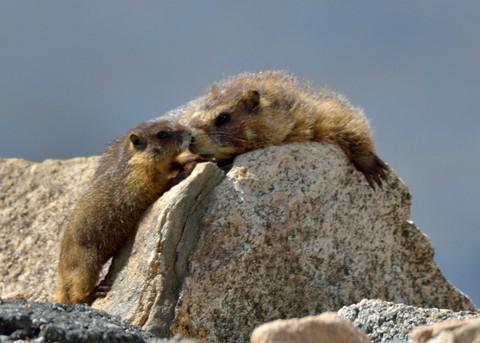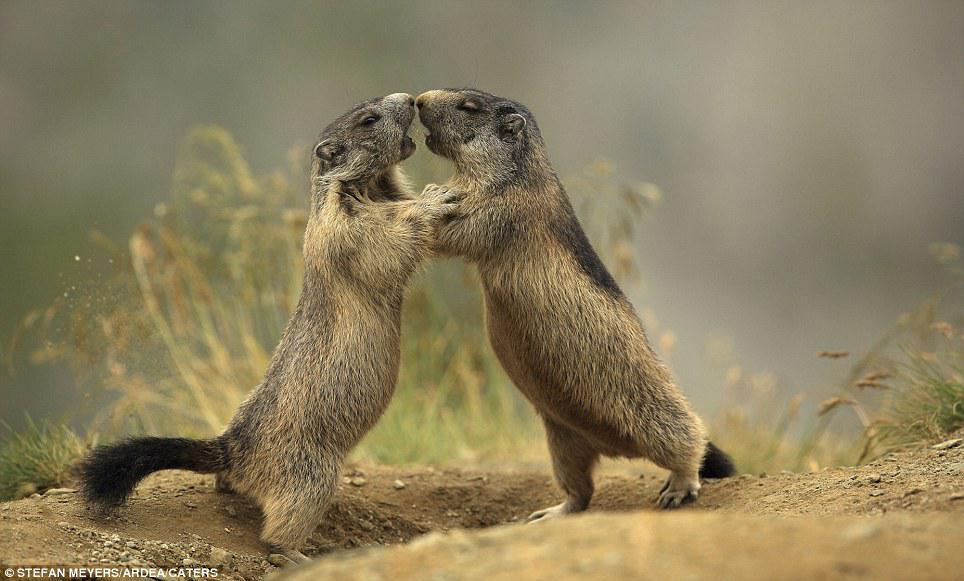The first image is the image on the left, the second image is the image on the right. For the images displayed, is the sentence "The left image contains two rodents that are face to face." factually correct? Answer yes or no. Yes. The first image is the image on the left, the second image is the image on the right. Examine the images to the left and right. Is the description "Two marmots are standing with arms around one another and noses touching, in a pose that looks like dancing." accurate? Answer yes or no. Yes. 